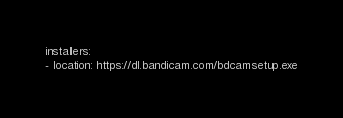<code> <loc_0><loc_0><loc_500><loc_500><_YAML_>installers:
- location: https://dl.bandicam.com/bdcamsetup.exe
</code> 